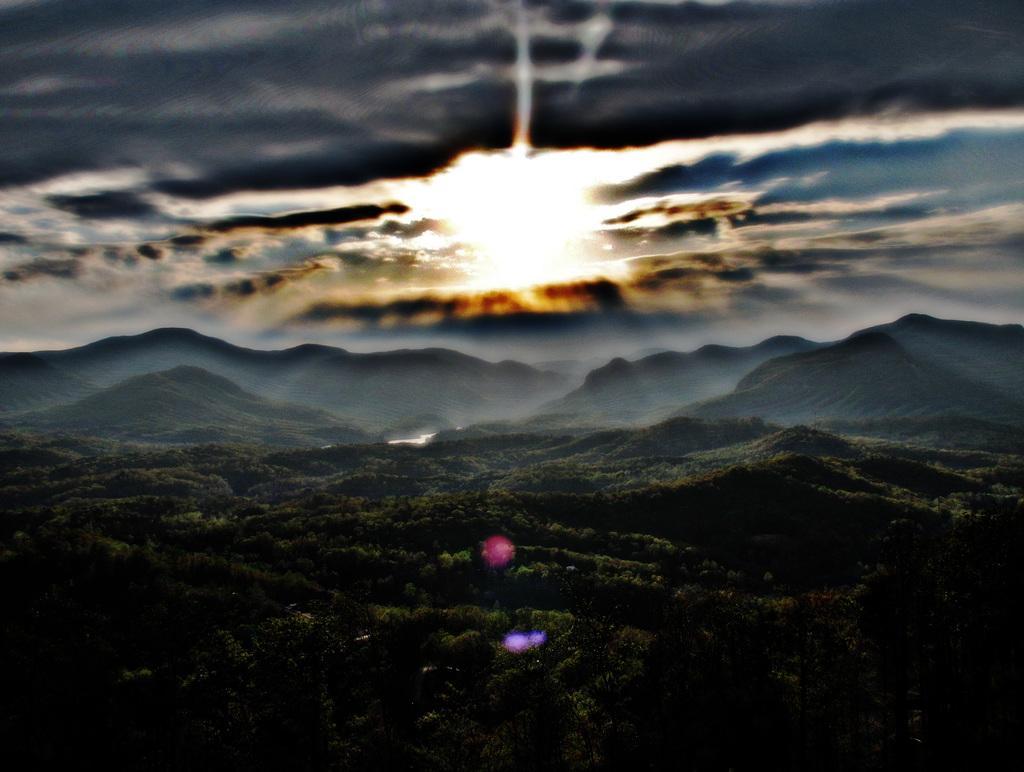In one or two sentences, can you explain what this image depicts? In the picture there are many trees, there are hills, there is a cloudy sky. 